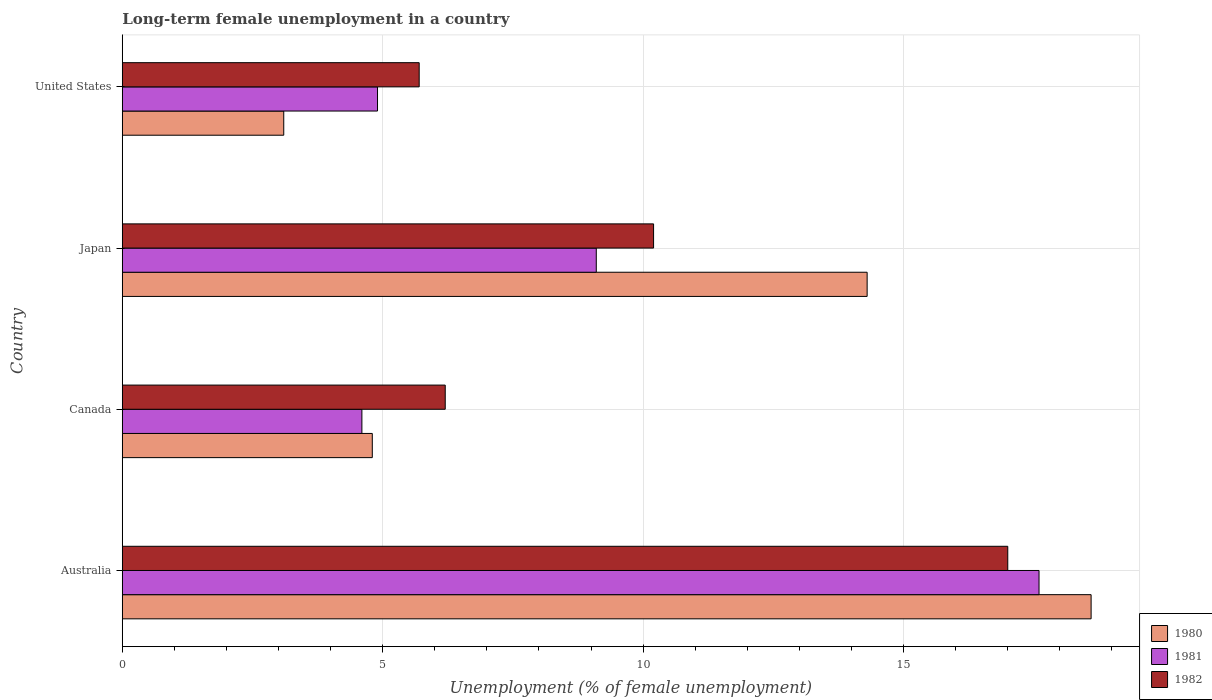How many bars are there on the 2nd tick from the bottom?
Offer a very short reply. 3. In how many cases, is the number of bars for a given country not equal to the number of legend labels?
Make the answer very short. 0. What is the percentage of long-term unemployed female population in 1981 in Japan?
Offer a very short reply. 9.1. Across all countries, what is the maximum percentage of long-term unemployed female population in 1981?
Keep it short and to the point. 17.6. Across all countries, what is the minimum percentage of long-term unemployed female population in 1980?
Your response must be concise. 3.1. What is the total percentage of long-term unemployed female population in 1980 in the graph?
Your answer should be compact. 40.8. What is the difference between the percentage of long-term unemployed female population in 1981 in Japan and that in United States?
Provide a short and direct response. 4.2. What is the difference between the percentage of long-term unemployed female population in 1982 in Japan and the percentage of long-term unemployed female population in 1981 in Australia?
Provide a short and direct response. -7.4. What is the average percentage of long-term unemployed female population in 1981 per country?
Provide a succinct answer. 9.05. What is the difference between the percentage of long-term unemployed female population in 1982 and percentage of long-term unemployed female population in 1980 in Japan?
Your answer should be very brief. -4.1. In how many countries, is the percentage of long-term unemployed female population in 1981 greater than 5 %?
Make the answer very short. 2. What is the ratio of the percentage of long-term unemployed female population in 1980 in Canada to that in United States?
Offer a very short reply. 1.55. Is the difference between the percentage of long-term unemployed female population in 1982 in Australia and Canada greater than the difference between the percentage of long-term unemployed female population in 1980 in Australia and Canada?
Offer a terse response. No. What is the difference between the highest and the second highest percentage of long-term unemployed female population in 1982?
Give a very brief answer. 6.8. What is the difference between the highest and the lowest percentage of long-term unemployed female population in 1982?
Your answer should be very brief. 11.3. What does the 2nd bar from the bottom in Japan represents?
Offer a very short reply. 1981. Is it the case that in every country, the sum of the percentage of long-term unemployed female population in 1982 and percentage of long-term unemployed female population in 1980 is greater than the percentage of long-term unemployed female population in 1981?
Make the answer very short. Yes. How many countries are there in the graph?
Make the answer very short. 4. Does the graph contain any zero values?
Give a very brief answer. No. Does the graph contain grids?
Your answer should be very brief. Yes. Where does the legend appear in the graph?
Your answer should be compact. Bottom right. How many legend labels are there?
Keep it short and to the point. 3. How are the legend labels stacked?
Your answer should be compact. Vertical. What is the title of the graph?
Ensure brevity in your answer.  Long-term female unemployment in a country. What is the label or title of the X-axis?
Provide a succinct answer. Unemployment (% of female unemployment). What is the Unemployment (% of female unemployment) of 1980 in Australia?
Keep it short and to the point. 18.6. What is the Unemployment (% of female unemployment) of 1981 in Australia?
Ensure brevity in your answer.  17.6. What is the Unemployment (% of female unemployment) of 1982 in Australia?
Your answer should be very brief. 17. What is the Unemployment (% of female unemployment) in 1980 in Canada?
Your answer should be compact. 4.8. What is the Unemployment (% of female unemployment) in 1981 in Canada?
Ensure brevity in your answer.  4.6. What is the Unemployment (% of female unemployment) of 1982 in Canada?
Make the answer very short. 6.2. What is the Unemployment (% of female unemployment) in 1980 in Japan?
Your answer should be very brief. 14.3. What is the Unemployment (% of female unemployment) of 1981 in Japan?
Your answer should be compact. 9.1. What is the Unemployment (% of female unemployment) of 1982 in Japan?
Ensure brevity in your answer.  10.2. What is the Unemployment (% of female unemployment) of 1980 in United States?
Give a very brief answer. 3.1. What is the Unemployment (% of female unemployment) of 1981 in United States?
Offer a terse response. 4.9. What is the Unemployment (% of female unemployment) in 1982 in United States?
Make the answer very short. 5.7. Across all countries, what is the maximum Unemployment (% of female unemployment) in 1980?
Ensure brevity in your answer.  18.6. Across all countries, what is the maximum Unemployment (% of female unemployment) of 1981?
Ensure brevity in your answer.  17.6. Across all countries, what is the maximum Unemployment (% of female unemployment) in 1982?
Offer a very short reply. 17. Across all countries, what is the minimum Unemployment (% of female unemployment) of 1980?
Keep it short and to the point. 3.1. Across all countries, what is the minimum Unemployment (% of female unemployment) of 1981?
Your answer should be very brief. 4.6. Across all countries, what is the minimum Unemployment (% of female unemployment) of 1982?
Keep it short and to the point. 5.7. What is the total Unemployment (% of female unemployment) in 1980 in the graph?
Make the answer very short. 40.8. What is the total Unemployment (% of female unemployment) in 1981 in the graph?
Offer a very short reply. 36.2. What is the total Unemployment (% of female unemployment) in 1982 in the graph?
Ensure brevity in your answer.  39.1. What is the difference between the Unemployment (% of female unemployment) in 1982 in Australia and that in Canada?
Your answer should be compact. 10.8. What is the difference between the Unemployment (% of female unemployment) in 1980 in Australia and that in Japan?
Make the answer very short. 4.3. What is the difference between the Unemployment (% of female unemployment) in 1981 in Australia and that in Japan?
Provide a succinct answer. 8.5. What is the difference between the Unemployment (% of female unemployment) in 1982 in Canada and that in Japan?
Keep it short and to the point. -4. What is the difference between the Unemployment (% of female unemployment) of 1980 in Canada and that in United States?
Your answer should be very brief. 1.7. What is the difference between the Unemployment (% of female unemployment) of 1980 in Japan and that in United States?
Your answer should be compact. 11.2. What is the difference between the Unemployment (% of female unemployment) of 1981 in Japan and that in United States?
Ensure brevity in your answer.  4.2. What is the difference between the Unemployment (% of female unemployment) in 1980 in Australia and the Unemployment (% of female unemployment) in 1981 in Japan?
Keep it short and to the point. 9.5. What is the difference between the Unemployment (% of female unemployment) of 1980 in Australia and the Unemployment (% of female unemployment) of 1982 in Japan?
Make the answer very short. 8.4. What is the difference between the Unemployment (% of female unemployment) of 1980 in Canada and the Unemployment (% of female unemployment) of 1982 in Japan?
Keep it short and to the point. -5.4. What is the difference between the Unemployment (% of female unemployment) in 1981 in Canada and the Unemployment (% of female unemployment) in 1982 in Japan?
Your answer should be compact. -5.6. What is the difference between the Unemployment (% of female unemployment) in 1980 in Canada and the Unemployment (% of female unemployment) in 1982 in United States?
Offer a very short reply. -0.9. What is the difference between the Unemployment (% of female unemployment) of 1981 in Canada and the Unemployment (% of female unemployment) of 1982 in United States?
Offer a very short reply. -1.1. What is the difference between the Unemployment (% of female unemployment) of 1980 in Japan and the Unemployment (% of female unemployment) of 1982 in United States?
Ensure brevity in your answer.  8.6. What is the average Unemployment (% of female unemployment) in 1981 per country?
Provide a short and direct response. 9.05. What is the average Unemployment (% of female unemployment) in 1982 per country?
Your answer should be compact. 9.78. What is the difference between the Unemployment (% of female unemployment) of 1980 and Unemployment (% of female unemployment) of 1981 in Australia?
Give a very brief answer. 1. What is the difference between the Unemployment (% of female unemployment) in 1980 and Unemployment (% of female unemployment) in 1982 in Canada?
Give a very brief answer. -1.4. What is the difference between the Unemployment (% of female unemployment) of 1980 and Unemployment (% of female unemployment) of 1981 in Japan?
Make the answer very short. 5.2. What is the difference between the Unemployment (% of female unemployment) in 1980 and Unemployment (% of female unemployment) in 1982 in Japan?
Your answer should be compact. 4.1. What is the ratio of the Unemployment (% of female unemployment) in 1980 in Australia to that in Canada?
Your answer should be very brief. 3.88. What is the ratio of the Unemployment (% of female unemployment) of 1981 in Australia to that in Canada?
Provide a short and direct response. 3.83. What is the ratio of the Unemployment (% of female unemployment) in 1982 in Australia to that in Canada?
Provide a succinct answer. 2.74. What is the ratio of the Unemployment (% of female unemployment) of 1980 in Australia to that in Japan?
Ensure brevity in your answer.  1.3. What is the ratio of the Unemployment (% of female unemployment) of 1981 in Australia to that in Japan?
Ensure brevity in your answer.  1.93. What is the ratio of the Unemployment (% of female unemployment) in 1980 in Australia to that in United States?
Your answer should be very brief. 6. What is the ratio of the Unemployment (% of female unemployment) in 1981 in Australia to that in United States?
Your answer should be compact. 3.59. What is the ratio of the Unemployment (% of female unemployment) in 1982 in Australia to that in United States?
Your answer should be very brief. 2.98. What is the ratio of the Unemployment (% of female unemployment) of 1980 in Canada to that in Japan?
Give a very brief answer. 0.34. What is the ratio of the Unemployment (% of female unemployment) in 1981 in Canada to that in Japan?
Keep it short and to the point. 0.51. What is the ratio of the Unemployment (% of female unemployment) of 1982 in Canada to that in Japan?
Provide a short and direct response. 0.61. What is the ratio of the Unemployment (% of female unemployment) in 1980 in Canada to that in United States?
Offer a terse response. 1.55. What is the ratio of the Unemployment (% of female unemployment) in 1981 in Canada to that in United States?
Provide a short and direct response. 0.94. What is the ratio of the Unemployment (% of female unemployment) of 1982 in Canada to that in United States?
Your answer should be very brief. 1.09. What is the ratio of the Unemployment (% of female unemployment) in 1980 in Japan to that in United States?
Keep it short and to the point. 4.61. What is the ratio of the Unemployment (% of female unemployment) in 1981 in Japan to that in United States?
Offer a terse response. 1.86. What is the ratio of the Unemployment (% of female unemployment) of 1982 in Japan to that in United States?
Provide a succinct answer. 1.79. What is the difference between the highest and the second highest Unemployment (% of female unemployment) of 1980?
Your answer should be compact. 4.3. What is the difference between the highest and the lowest Unemployment (% of female unemployment) in 1980?
Offer a very short reply. 15.5. What is the difference between the highest and the lowest Unemployment (% of female unemployment) in 1981?
Provide a short and direct response. 13. 